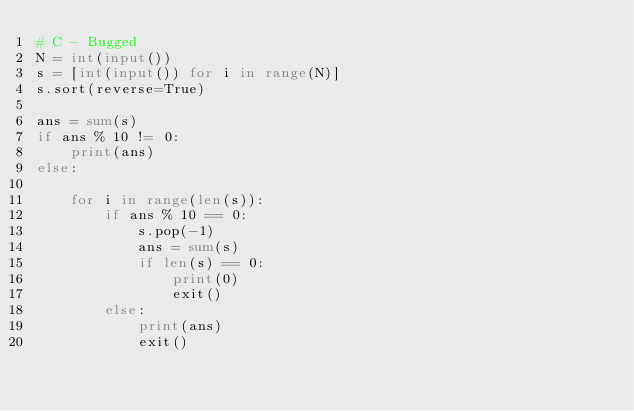<code> <loc_0><loc_0><loc_500><loc_500><_Python_># C - Bugged
N = int(input())
s = [int(input()) for i in range(N)]
s.sort(reverse=True)

ans = sum(s)
if ans % 10 != 0:
    print(ans)
else:

    for i in range(len(s)):
        if ans % 10 == 0:
            s.pop(-1)
            ans = sum(s)
            if len(s) == 0:
                print(0)
                exit()
        else:
            print(ans)
            exit()
</code> 